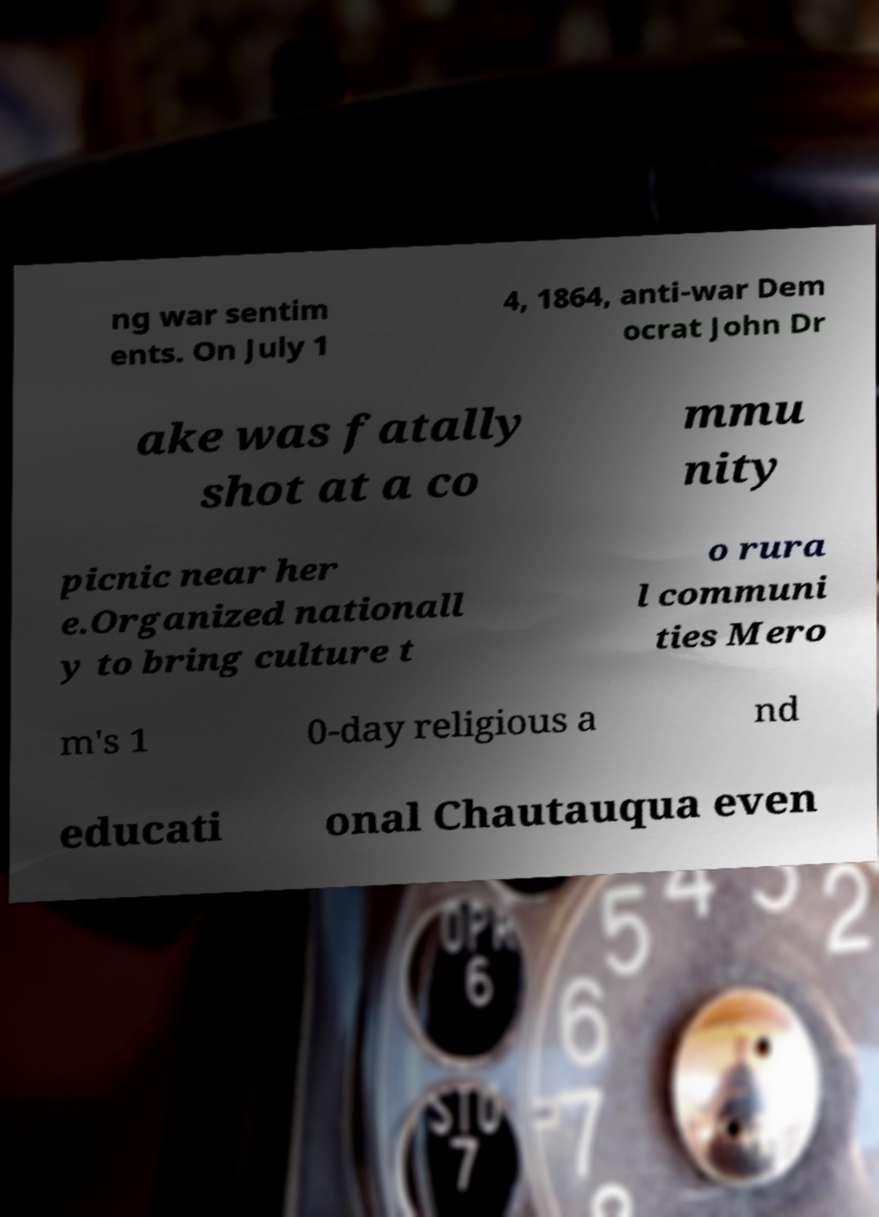Could you assist in decoding the text presented in this image and type it out clearly? ng war sentim ents. On July 1 4, 1864, anti-war Dem ocrat John Dr ake was fatally shot at a co mmu nity picnic near her e.Organized nationall y to bring culture t o rura l communi ties Mero m's 1 0-day religious a nd educati onal Chautauqua even 